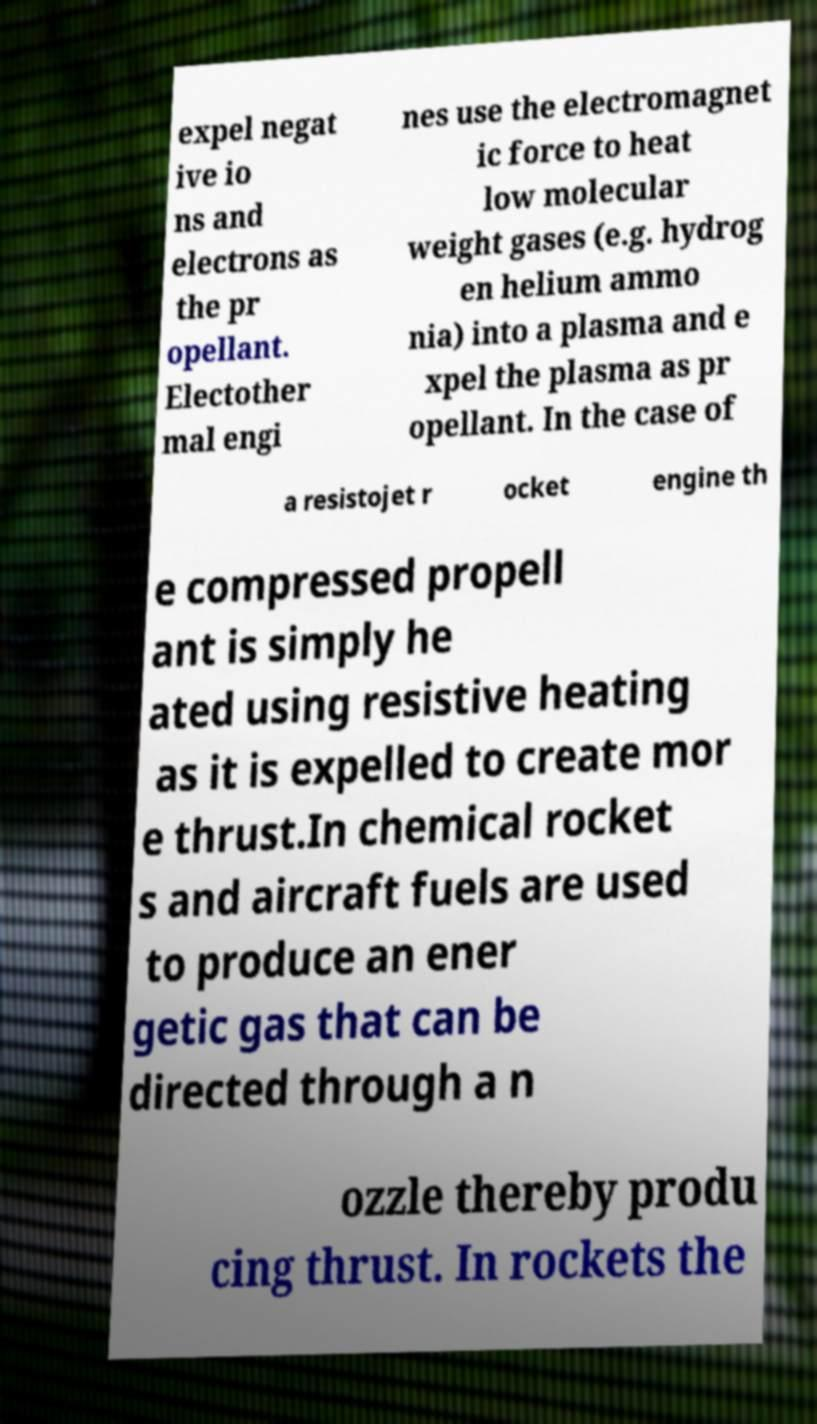Could you assist in decoding the text presented in this image and type it out clearly? expel negat ive io ns and electrons as the pr opellant. Electother mal engi nes use the electromagnet ic force to heat low molecular weight gases (e.g. hydrog en helium ammo nia) into a plasma and e xpel the plasma as pr opellant. In the case of a resistojet r ocket engine th e compressed propell ant is simply he ated using resistive heating as it is expelled to create mor e thrust.In chemical rocket s and aircraft fuels are used to produce an ener getic gas that can be directed through a n ozzle thereby produ cing thrust. In rockets the 